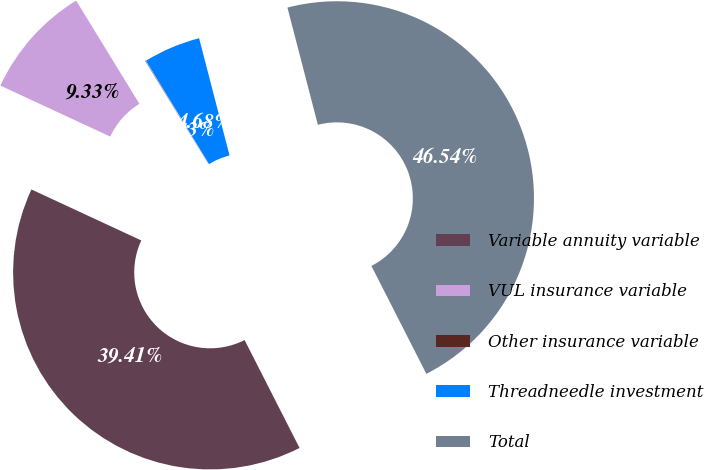Convert chart. <chart><loc_0><loc_0><loc_500><loc_500><pie_chart><fcel>Variable annuity variable<fcel>VUL insurance variable<fcel>Other insurance variable<fcel>Threadneedle investment<fcel>Total<nl><fcel>39.41%<fcel>9.33%<fcel>0.03%<fcel>4.68%<fcel>46.54%<nl></chart> 